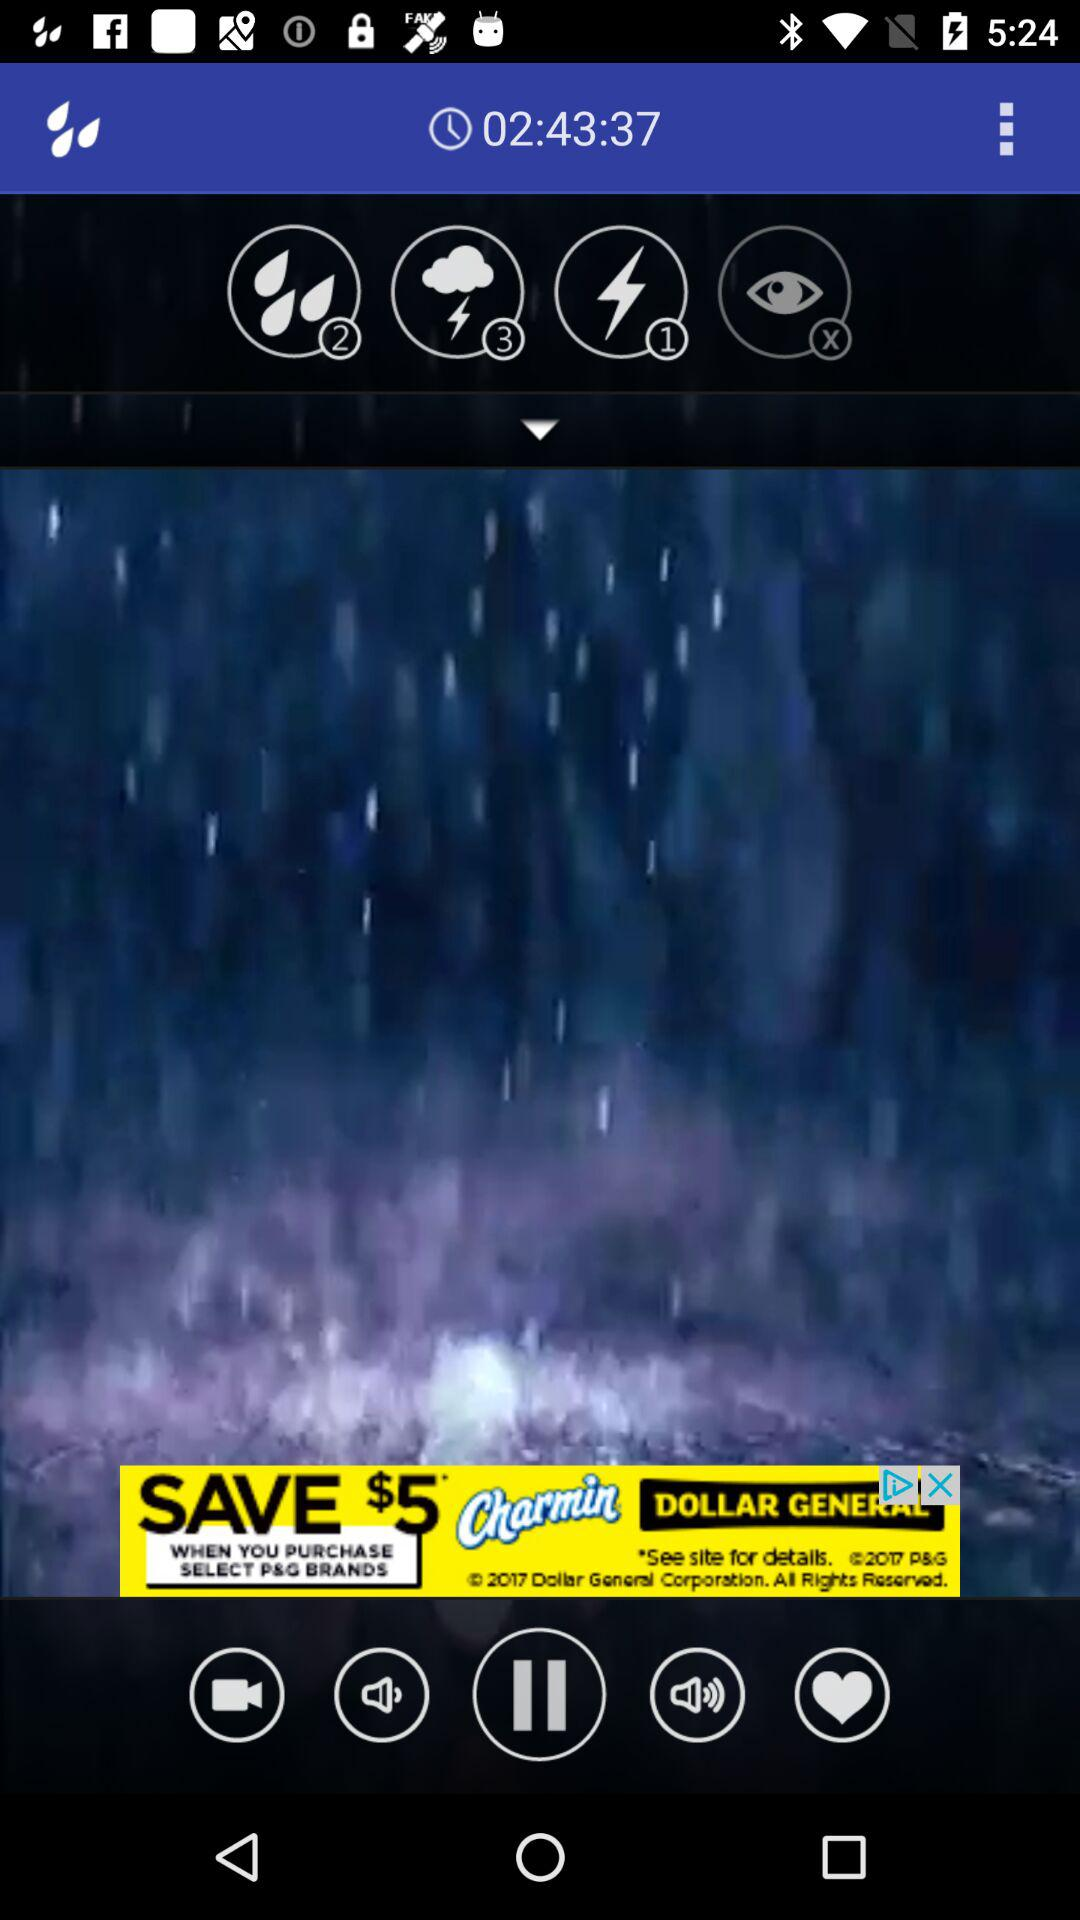What is the mentioned time? The mentioned time is 02:43:37. 